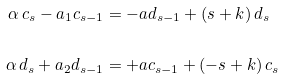<formula> <loc_0><loc_0><loc_500><loc_500>\alpha \, c _ { s } - a _ { 1 } c _ { s - 1 } & = - a d _ { s - 1 } + ( s + k ) \, d _ { s } \\ \\ \alpha \, d _ { s } + a _ { 2 } d _ { s - 1 } & = + a c _ { s - 1 } + ( - s + k ) \, c _ { s }</formula> 